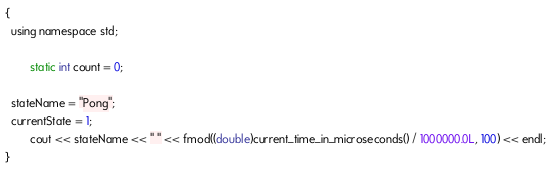<code> <loc_0><loc_0><loc_500><loc_500><_ObjectiveC_>{
  using namespace std;

        static int count = 0;

  stateName = "Pong";
  currentState = 1;
        cout << stateName << " " << fmod((double)current_time_in_microseconds() / 1000000.0L, 100) << endl;
}
</code> 